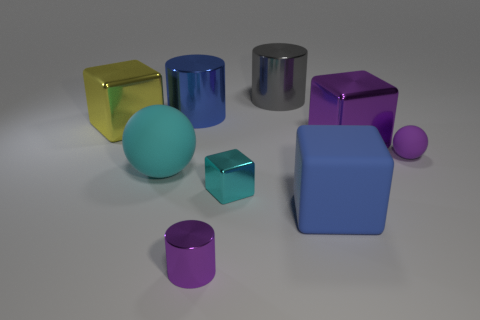Subtract 1 cubes. How many cubes are left? 3 Add 1 tiny gray rubber cylinders. How many objects exist? 10 Subtract all blocks. How many objects are left? 5 Subtract 1 blue cylinders. How many objects are left? 8 Subtract all large rubber spheres. Subtract all tiny purple spheres. How many objects are left? 7 Add 6 matte objects. How many matte objects are left? 9 Add 5 gray metallic cylinders. How many gray metallic cylinders exist? 6 